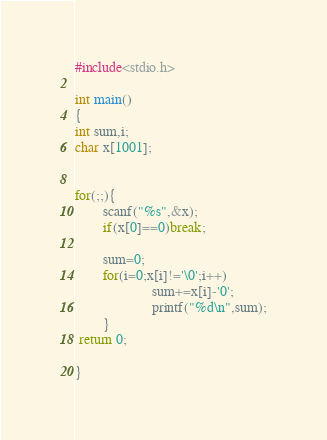Convert code to text. <code><loc_0><loc_0><loc_500><loc_500><_C_>#include<stdio.h>

int main()
{
int sum,i;
char x[1001];


for(;;){
        scanf("%s",&x);
        if(x[0]==0)break;

        sum=0;
        for(i=0;x[i]!='\0';i++)
                      sum+=x[i]-'0';
                      printf("%d\n",sum);
        }
 return 0;

}

</code> 